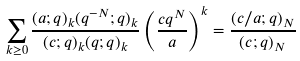Convert formula to latex. <formula><loc_0><loc_0><loc_500><loc_500>\sum _ { k \geq 0 } \frac { ( a ; q ) _ { k } ( q ^ { - N } ; q ) _ { k } } { ( c ; q ) _ { k } ( q ; q ) _ { k } } \left ( \frac { c q ^ { N } } { a } \right ) ^ { k } = \frac { ( c / a ; q ) _ { N } } { ( c ; q ) _ { N } }</formula> 